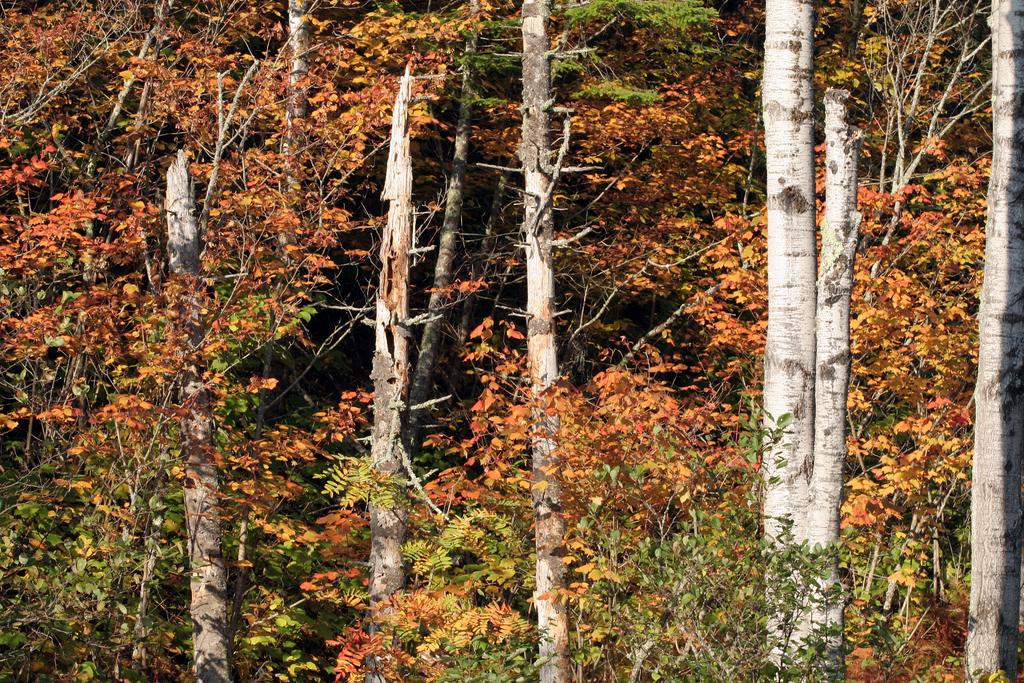What type of vegetation can be seen in the image? There is a thicket in the image. How tall are the trees in the thicket? The trees in the thicket are tall. What color are the leaves on the trees? The leaves on the trees are orange. Can you see a plane flying over the field in the image? There is no plane or field present in the image; it features a thicket with tall trees and orange leaves. 